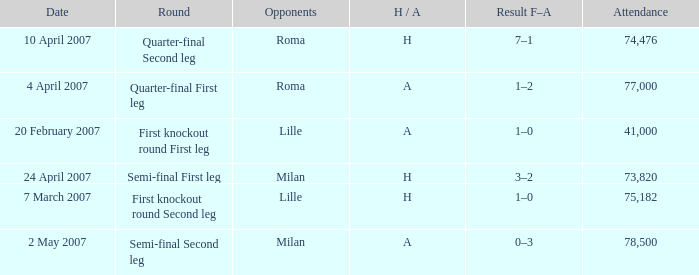Which round happened on 10 april 2007? Quarter-final Second leg. 